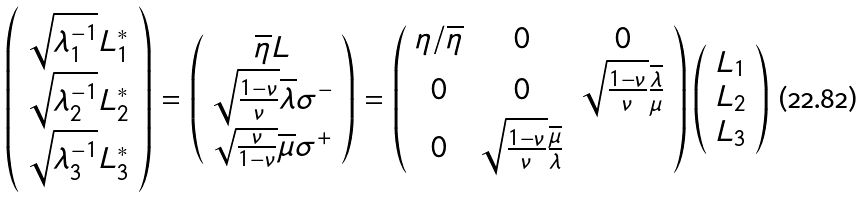<formula> <loc_0><loc_0><loc_500><loc_500>\left ( \begin{array} { c c c } \sqrt { \lambda _ { 1 } ^ { - 1 } } L ^ { * } _ { 1 } \\ \sqrt { \lambda _ { 2 } ^ { - 1 } } L ^ { * } _ { 2 } \\ \sqrt { \lambda _ { 3 } ^ { - 1 } } L ^ { * } _ { 3 } \end{array} \right ) = \left ( \begin{array} { c c c } \overline { \eta } L \\ \sqrt { \frac { 1 - \nu } { \nu } } \overline { \lambda } \sigma ^ { - } \\ \sqrt { \frac { \nu } { 1 - \nu } } \overline { \mu } \sigma ^ { + } \end{array} \right ) = \left ( \begin{array} { c c c } \eta / \overline { \eta } & 0 & 0 \\ 0 & 0 & \sqrt { \frac { 1 - \nu } { \nu } } \frac { \overline { \lambda } } { \mu } \\ 0 & \sqrt { \frac { 1 - \nu } { \nu } } \frac { \overline { \mu } } { \lambda } \end{array} \right ) \left ( \begin{array} { c c c } L _ { 1 } \\ L _ { 2 } \\ L _ { 3 } \end{array} \right )</formula> 